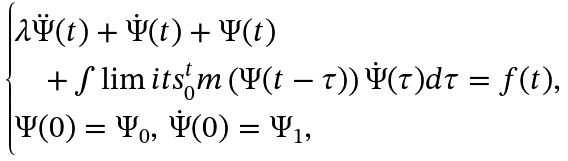<formula> <loc_0><loc_0><loc_500><loc_500>\begin{cases} \lambda \ddot { \Psi } ( t ) + \dot { \Psi } ( t ) + \Psi ( t ) \\ \quad + \int \lim i t s _ { 0 } ^ { t } m \left ( \Psi ( t - \tau ) \right ) \dot { \Psi } ( \tau ) d \tau = f ( t ) , \\ \Psi ( 0 ) = \Psi _ { 0 } , \, \dot { \Psi } ( 0 ) = \Psi _ { 1 } , \end{cases}</formula> 